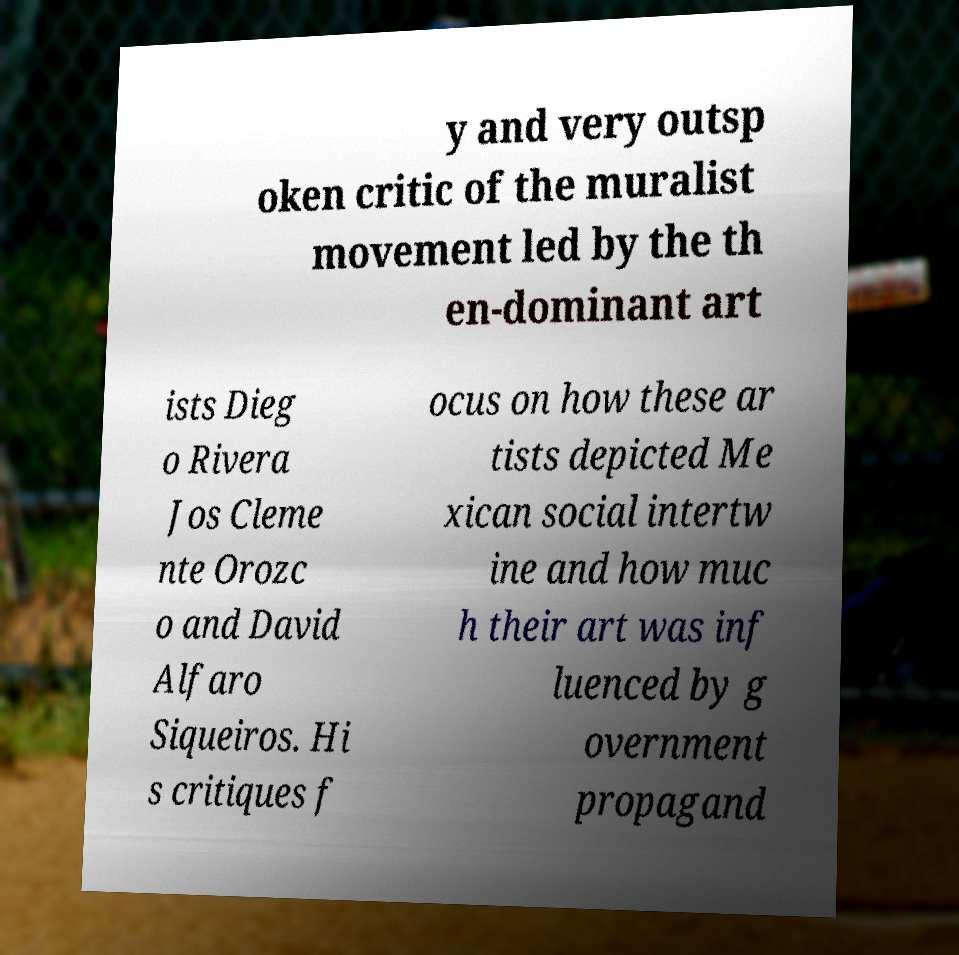Could you assist in decoding the text presented in this image and type it out clearly? y and very outsp oken critic of the muralist movement led by the th en-dominant art ists Dieg o Rivera Jos Cleme nte Orozc o and David Alfaro Siqueiros. Hi s critiques f ocus on how these ar tists depicted Me xican social intertw ine and how muc h their art was inf luenced by g overnment propagand 